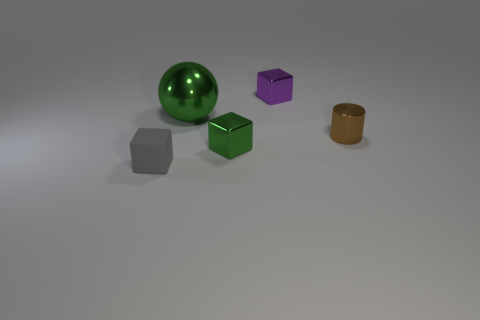Add 4 small gray rubber spheres. How many objects exist? 9 Subtract all spheres. How many objects are left? 4 Subtract all large green shiny things. Subtract all gray things. How many objects are left? 3 Add 1 small matte things. How many small matte things are left? 2 Add 1 green metal spheres. How many green metal spheres exist? 2 Subtract 0 yellow blocks. How many objects are left? 5 